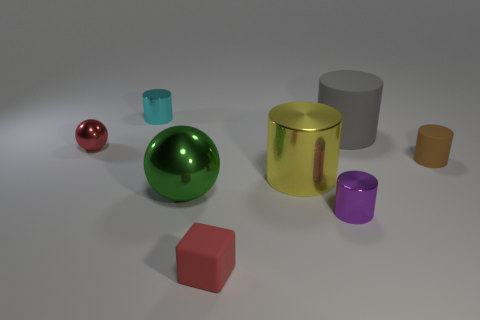Subtract all tiny cyan metal cylinders. How many cylinders are left? 4 Add 1 gray cylinders. How many objects exist? 9 Subtract all red spheres. How many spheres are left? 1 Subtract all tiny red objects. Subtract all tiny blocks. How many objects are left? 5 Add 1 small rubber cubes. How many small rubber cubes are left? 2 Add 2 gray rubber things. How many gray rubber things exist? 3 Subtract 0 cyan balls. How many objects are left? 8 Subtract all blocks. How many objects are left? 7 Subtract 1 balls. How many balls are left? 1 Subtract all yellow spheres. Subtract all red cylinders. How many spheres are left? 2 